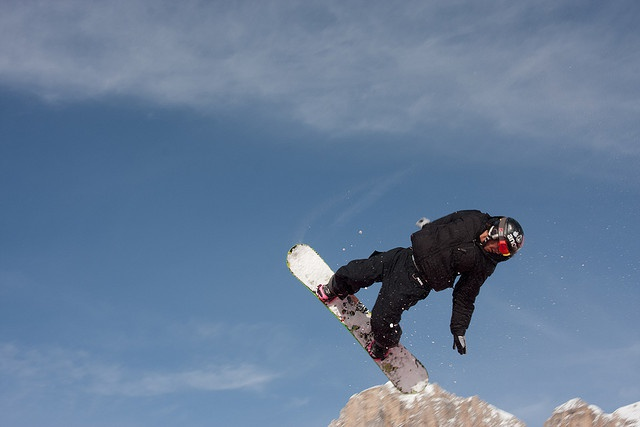Describe the objects in this image and their specific colors. I can see people in gray, black, maroon, and darkgray tones and snowboard in gray, lightgray, and darkgray tones in this image. 